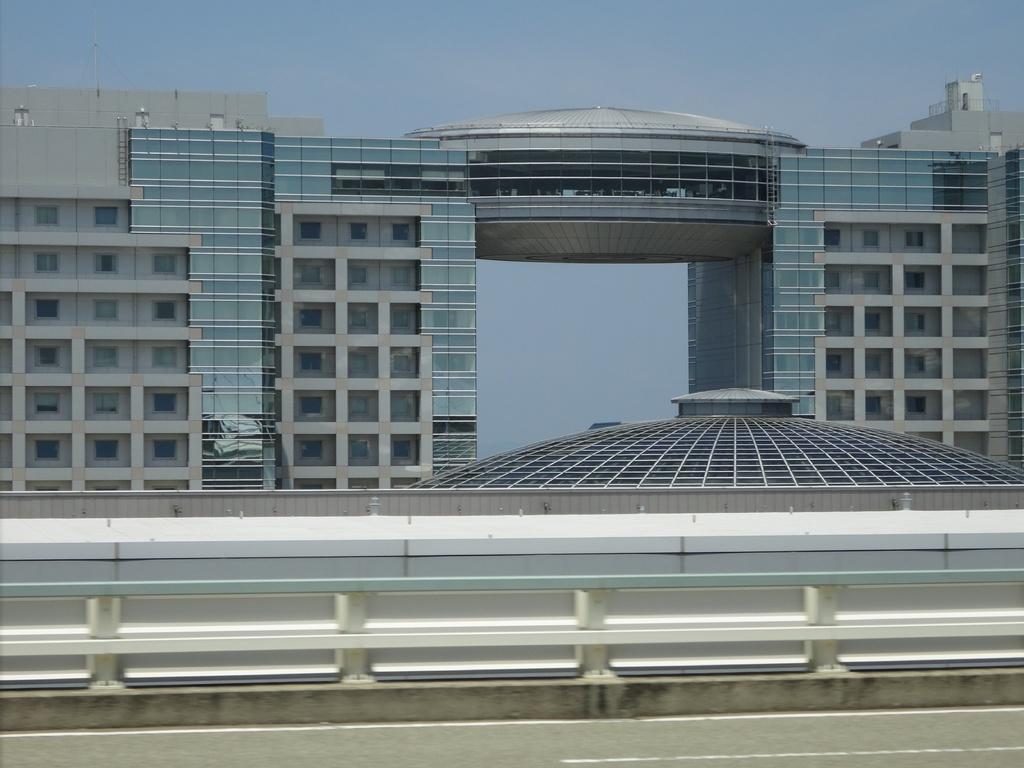In one or two sentences, can you explain what this image depicts? In this image there is a road at the bottom. Beside the road there is fence. In the background there are tall buildings with the glasses. At the top there is the sky. 